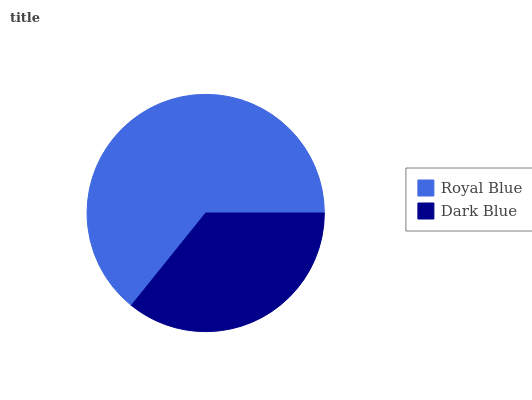Is Dark Blue the minimum?
Answer yes or no. Yes. Is Royal Blue the maximum?
Answer yes or no. Yes. Is Dark Blue the maximum?
Answer yes or no. No. Is Royal Blue greater than Dark Blue?
Answer yes or no. Yes. Is Dark Blue less than Royal Blue?
Answer yes or no. Yes. Is Dark Blue greater than Royal Blue?
Answer yes or no. No. Is Royal Blue less than Dark Blue?
Answer yes or no. No. Is Royal Blue the high median?
Answer yes or no. Yes. Is Dark Blue the low median?
Answer yes or no. Yes. Is Dark Blue the high median?
Answer yes or no. No. Is Royal Blue the low median?
Answer yes or no. No. 